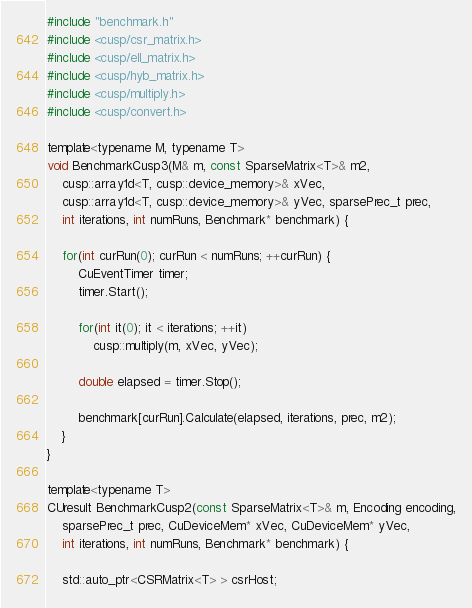<code> <loc_0><loc_0><loc_500><loc_500><_Cuda_>#include "benchmark.h"
#include <cusp/csr_matrix.h>
#include <cusp/ell_matrix.h>
#include <cusp/hyb_matrix.h>
#include <cusp/multiply.h>
#include <cusp/convert.h>

template<typename M, typename T>
void BenchmarkCusp3(M& m, const SparseMatrix<T>& m2, 
	cusp::array1d<T, cusp::device_memory>& xVec, 
	cusp::array1d<T, cusp::device_memory>& yVec, sparsePrec_t prec,
	int iterations, int numRuns, Benchmark* benchmark) {

	for(int curRun(0); curRun < numRuns; ++curRun) {
		CuEventTimer timer;
		timer.Start();

		for(int it(0); it < iterations; ++it)
			cusp::multiply(m, xVec, yVec);

		double elapsed = timer.Stop();

		benchmark[curRun].Calculate(elapsed, iterations, prec, m2);
	}
}

template<typename T>
CUresult BenchmarkCusp2(const SparseMatrix<T>& m, Encoding encoding,
	sparsePrec_t prec, CuDeviceMem* xVec, CuDeviceMem* yVec,
	int iterations, int numRuns, Benchmark* benchmark) {

	std::auto_ptr<CSRMatrix<T> > csrHost;</code> 